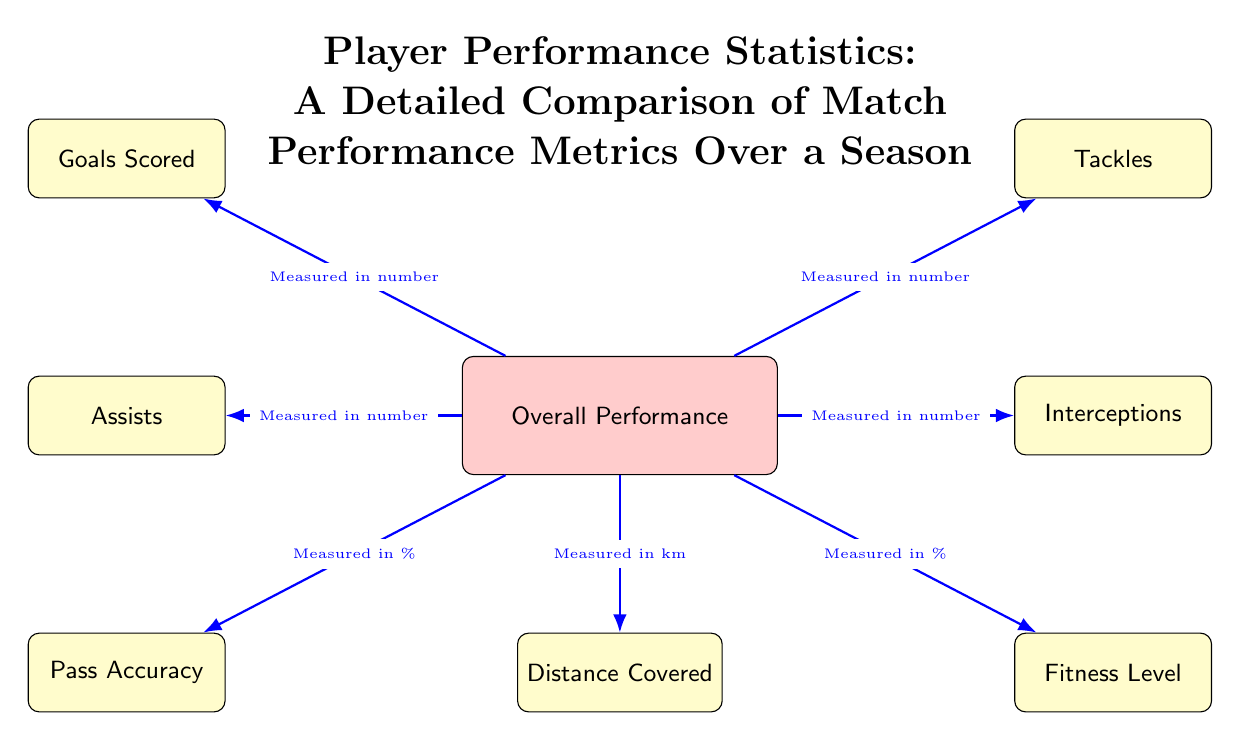What is the main focus of the diagram? The main focus is represented by the node labeled "Overall Performance," which captures the overall statistics for player performance evaluation.
Answer: Overall Performance How many metrics are listed in the diagram? There are six metric nodes connected to the central node, indicating the different performance statistics being measured.
Answer: Six What metric is measured in kilometers? The node labeled "Distance Covered" is specifically noted for being measured in kilometers.
Answer: Distance Covered Which performance metric has an accuracy percentage associated with it? The "Pass Accuracy" node is the one that relates to a percentage measurement, indicating how effectively passes are completed.
Answer: Pass Accuracy If a player's fitness level is 85 percent, how does it relate to their overall performance? Fitness Level, indicated as a percentage node, directly influences the overall performance, suggesting that a higher fitness level can contribute positively to overall metrics.
Answer: Influences Overall Performance 